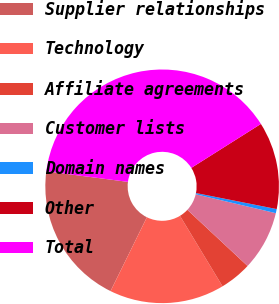<chart> <loc_0><loc_0><loc_500><loc_500><pie_chart><fcel>Supplier relationships<fcel>Technology<fcel>Affiliate agreements<fcel>Customer lists<fcel>Domain names<fcel>Other<fcel>Total<nl><fcel>19.77%<fcel>15.93%<fcel>4.41%<fcel>8.25%<fcel>0.57%<fcel>12.09%<fcel>38.98%<nl></chart> 